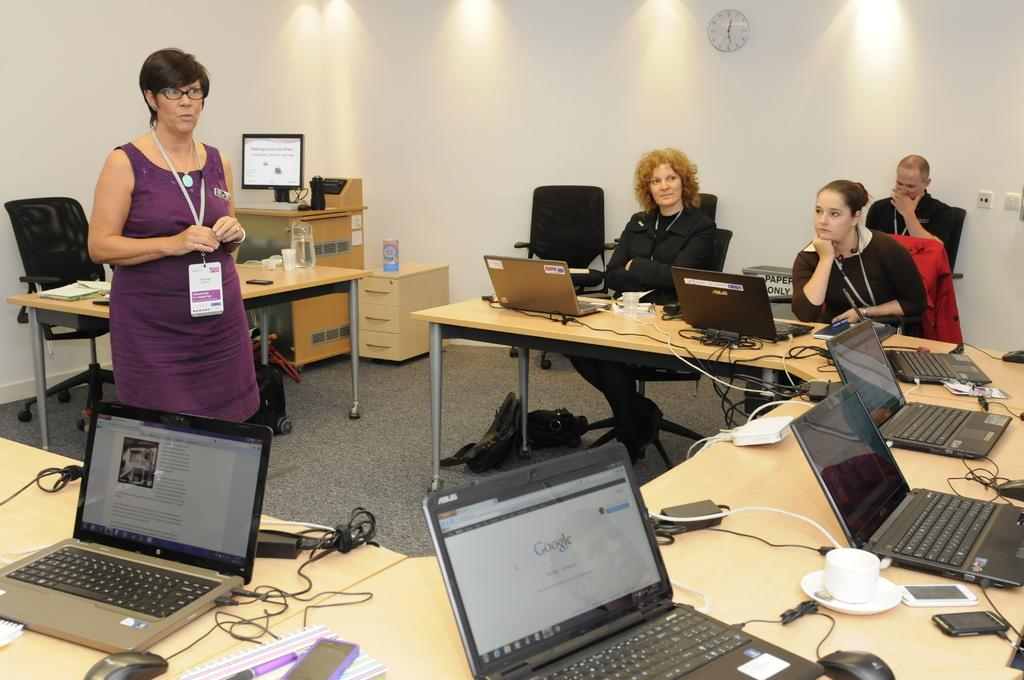Provide a one-sentence caption for the provided image. People sit at tables around a woman, with their computers open to Google and other webpages. 